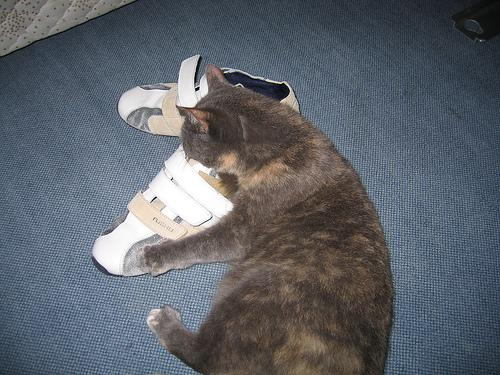What type of surface is the cat on? A blue carpet. Explain what the cat is doing in relation to the shoe. The cat is sniffing, playing with and putting its head inside the shoe. Mention a detail about the shoe pertaining to its brand. The brand name of the shoe is written on the front strap. Describe the position of the cat and its interaction with the object. The cat is laying on its side while engaging with the shoe, sniffing and putting its head inside. Describe the overall mood or sentiment of the image. A playful and curious interaction between a cat and a pair of sneakers. Identify the type of footwear that the cat is interacting with. A pair of white and grey sneakers with velcro straps. What kind of laces do the sneakers have? The sneakers have velcro laces. What is the primary color of the cat in the image? Brown and grey. List three distinctive features of the cat. Pink ears, white paw fur, and brown-grey color. Count the number of sneakers shown in the image. There is a pair of sneakers, so two. 